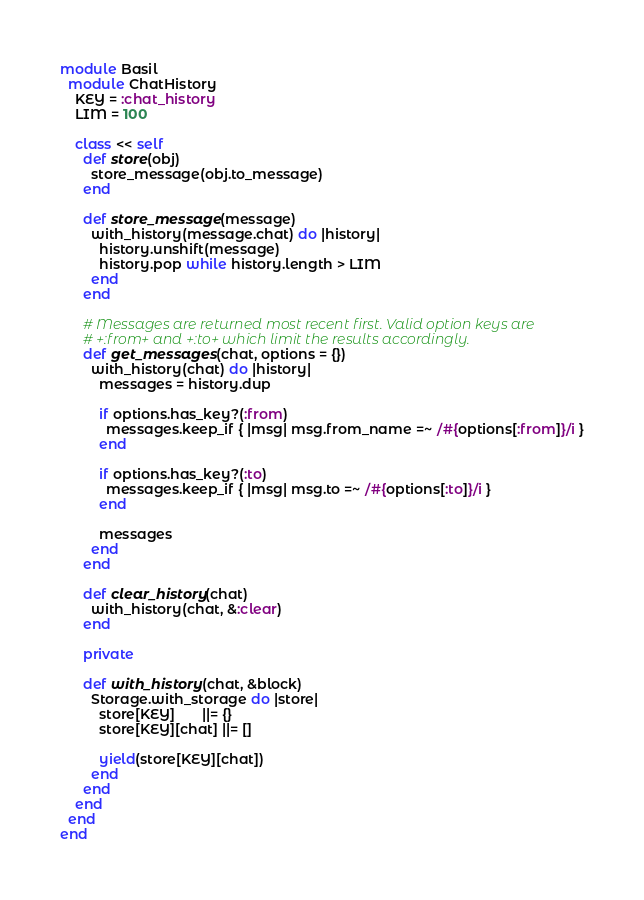<code> <loc_0><loc_0><loc_500><loc_500><_Ruby_>module Basil
  module ChatHistory
    KEY = :chat_history
    LIM = 100

    class << self
      def store(obj)
        store_message(obj.to_message)
      end

      def store_message(message)
        with_history(message.chat) do |history|
          history.unshift(message)
          history.pop while history.length > LIM
        end
      end

      # Messages are returned most recent first. Valid option keys are
      # +:from+ and +:to+ which limit the results accordingly.
      def get_messages(chat, options = {})
        with_history(chat) do |history|
          messages = history.dup

          if options.has_key?(:from)
            messages.keep_if { |msg| msg.from_name =~ /#{options[:from]}/i }
          end

          if options.has_key?(:to)
            messages.keep_if { |msg| msg.to =~ /#{options[:to]}/i }
          end

          messages
        end
      end

      def clear_history(chat)
        with_history(chat, &:clear)
      end

      private

      def with_history(chat, &block)
        Storage.with_storage do |store|
          store[KEY]       ||= {}
          store[KEY][chat] ||= []

          yield(store[KEY][chat])
        end
      end
    end
  end
end
</code> 